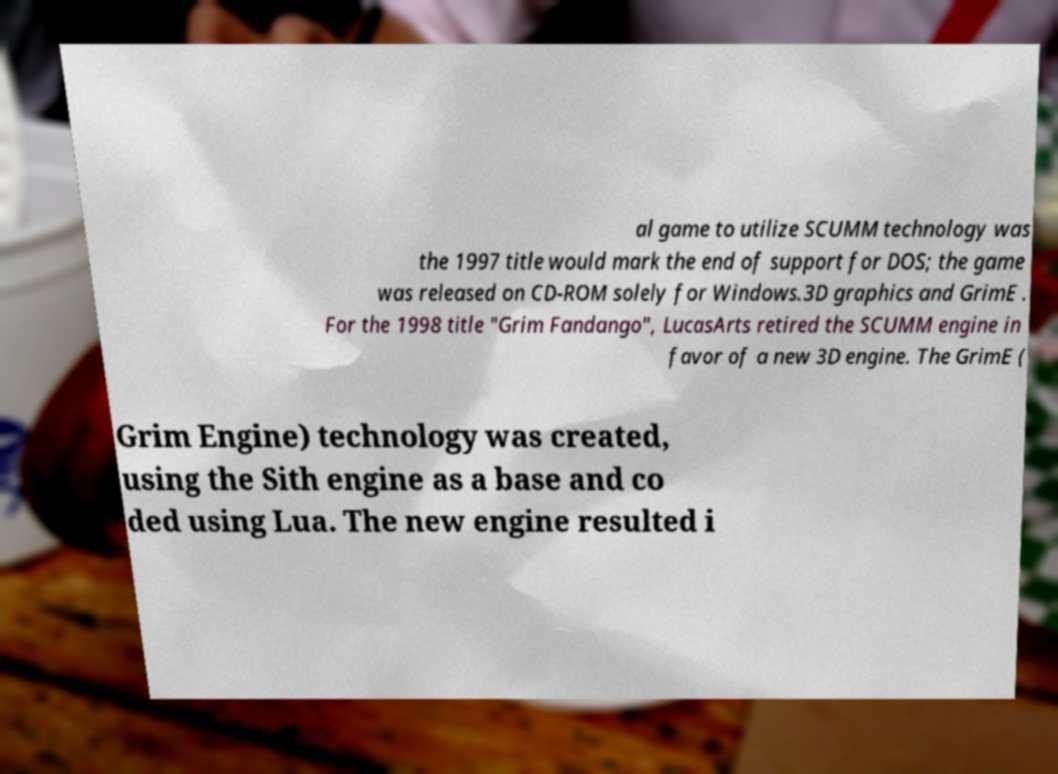I need the written content from this picture converted into text. Can you do that? al game to utilize SCUMM technology was the 1997 title would mark the end of support for DOS; the game was released on CD-ROM solely for Windows.3D graphics and GrimE . For the 1998 title "Grim Fandango", LucasArts retired the SCUMM engine in favor of a new 3D engine. The GrimE ( Grim Engine) technology was created, using the Sith engine as a base and co ded using Lua. The new engine resulted i 